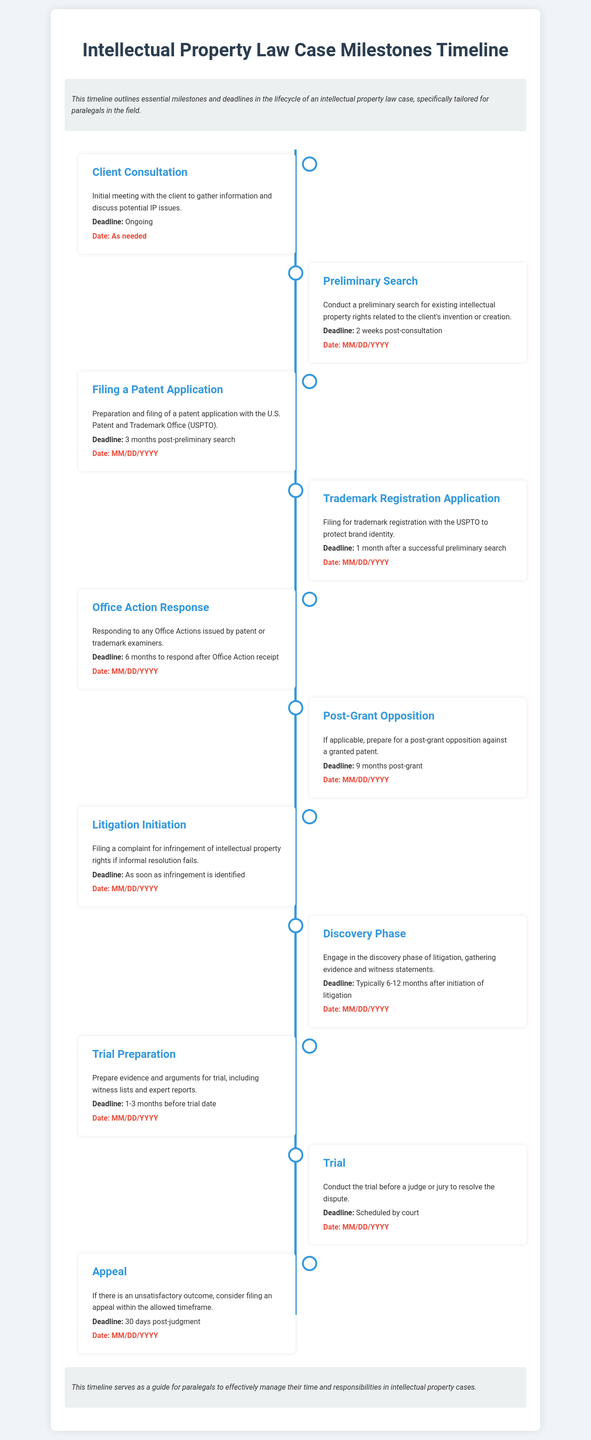What is the first milestone in the timeline? The first milestone is “Client Consultation,” which is the initial meeting to gather information and discuss potential IP issues.
Answer: Client Consultation How long after the consultation should a preliminary search be conducted? The timeline specifies that a preliminary search should be completed 2 weeks post-consultation.
Answer: 2 weeks What is the deadline for filing a patent application? The patent application must be filed 3 months post-preliminary search according to the timeline.
Answer: 3 months What action should be taken if there is an unsatisfactory trial outcome? The document states that one should consider filing an appeal within the allowed timeframe if the trial outcome is unsatisfactory.
Answer: File an appeal How long do you have to respond to an Office Action? The timeline indicates that there is a 6-month deadline to respond after receiving an Office Action.
Answer: 6 months What is the maximum time frame for trial preparation? According to the timeline, trial preparation should be completed 1-3 months before the trial date.
Answer: 1-3 months What stage follows immediately after the initiation of litigation? The next stage in the timeline after litigation initiation is the discovery phase, where evidence and witness statements are gathered.
Answer: Discovery Phase What is the date associated with trademark registration application filings? The filing for trademark registration should occur 1 month after a successful preliminary search, as outlined in the timeline.
Answer: 1 month after preliminary search 